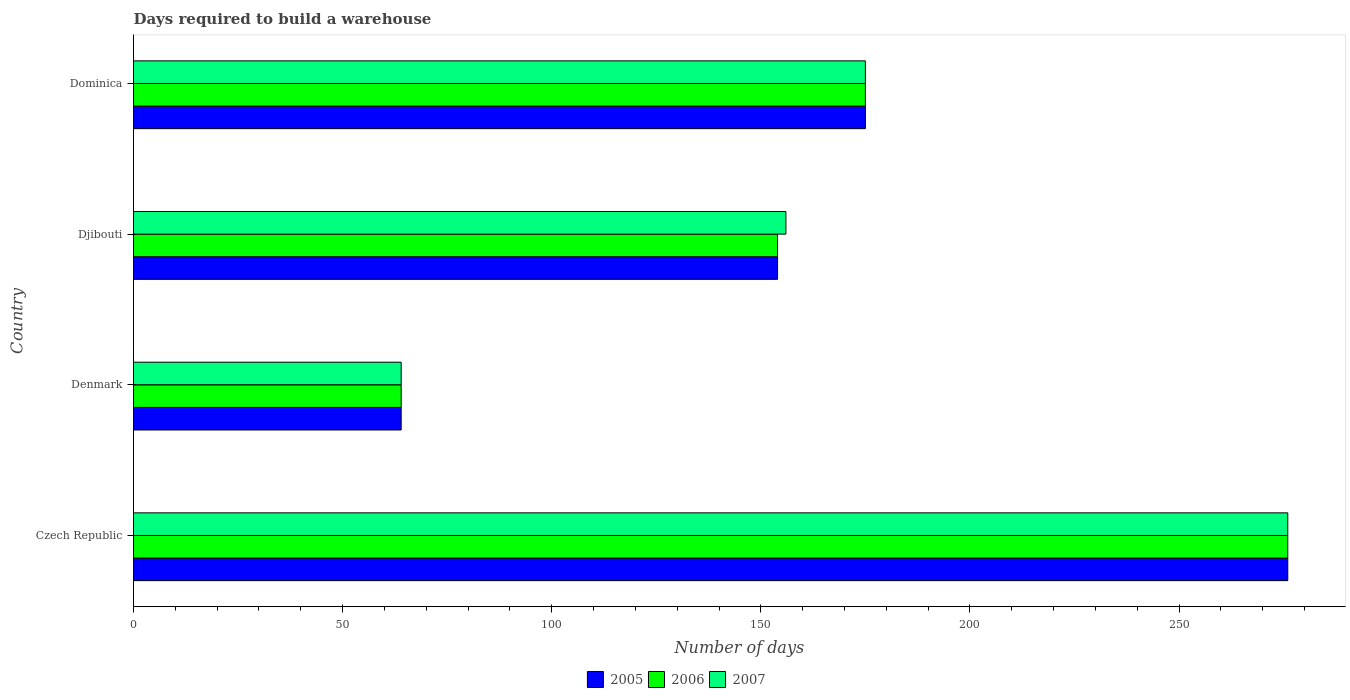How many bars are there on the 3rd tick from the bottom?
Offer a very short reply. 3. In how many cases, is the number of bars for a given country not equal to the number of legend labels?
Give a very brief answer. 0. What is the days required to build a warehouse in in 2005 in Denmark?
Your response must be concise. 64. Across all countries, what is the maximum days required to build a warehouse in in 2007?
Make the answer very short. 276. Across all countries, what is the minimum days required to build a warehouse in in 2005?
Give a very brief answer. 64. In which country was the days required to build a warehouse in in 2007 maximum?
Make the answer very short. Czech Republic. In which country was the days required to build a warehouse in in 2006 minimum?
Your answer should be compact. Denmark. What is the total days required to build a warehouse in in 2007 in the graph?
Make the answer very short. 671. What is the difference between the days required to build a warehouse in in 2006 in Denmark and that in Dominica?
Offer a very short reply. -111. What is the difference between the days required to build a warehouse in in 2006 in Denmark and the days required to build a warehouse in in 2007 in Dominica?
Ensure brevity in your answer.  -111. What is the average days required to build a warehouse in in 2007 per country?
Ensure brevity in your answer.  167.75. What is the ratio of the days required to build a warehouse in in 2005 in Denmark to that in Djibouti?
Offer a very short reply. 0.42. What is the difference between the highest and the second highest days required to build a warehouse in in 2006?
Provide a succinct answer. 101. What is the difference between the highest and the lowest days required to build a warehouse in in 2007?
Offer a very short reply. 212. What does the 1st bar from the top in Czech Republic represents?
Give a very brief answer. 2007. Is it the case that in every country, the sum of the days required to build a warehouse in in 2007 and days required to build a warehouse in in 2006 is greater than the days required to build a warehouse in in 2005?
Your answer should be very brief. Yes. How many bars are there?
Keep it short and to the point. 12. How many countries are there in the graph?
Provide a short and direct response. 4. Are the values on the major ticks of X-axis written in scientific E-notation?
Offer a terse response. No. Does the graph contain any zero values?
Offer a very short reply. No. How are the legend labels stacked?
Your response must be concise. Horizontal. What is the title of the graph?
Provide a short and direct response. Days required to build a warehouse. Does "1965" appear as one of the legend labels in the graph?
Offer a terse response. No. What is the label or title of the X-axis?
Give a very brief answer. Number of days. What is the label or title of the Y-axis?
Your answer should be compact. Country. What is the Number of days of 2005 in Czech Republic?
Ensure brevity in your answer.  276. What is the Number of days of 2006 in Czech Republic?
Ensure brevity in your answer.  276. What is the Number of days in 2007 in Czech Republic?
Offer a terse response. 276. What is the Number of days in 2005 in Djibouti?
Your answer should be very brief. 154. What is the Number of days in 2006 in Djibouti?
Offer a very short reply. 154. What is the Number of days in 2007 in Djibouti?
Provide a succinct answer. 156. What is the Number of days of 2005 in Dominica?
Offer a terse response. 175. What is the Number of days of 2006 in Dominica?
Your answer should be compact. 175. What is the Number of days in 2007 in Dominica?
Your response must be concise. 175. Across all countries, what is the maximum Number of days of 2005?
Provide a short and direct response. 276. Across all countries, what is the maximum Number of days of 2006?
Offer a very short reply. 276. Across all countries, what is the maximum Number of days in 2007?
Offer a terse response. 276. Across all countries, what is the minimum Number of days of 2005?
Your answer should be compact. 64. Across all countries, what is the minimum Number of days of 2006?
Offer a very short reply. 64. Across all countries, what is the minimum Number of days of 2007?
Offer a very short reply. 64. What is the total Number of days of 2005 in the graph?
Provide a succinct answer. 669. What is the total Number of days in 2006 in the graph?
Make the answer very short. 669. What is the total Number of days in 2007 in the graph?
Keep it short and to the point. 671. What is the difference between the Number of days in 2005 in Czech Republic and that in Denmark?
Your answer should be very brief. 212. What is the difference between the Number of days of 2006 in Czech Republic and that in Denmark?
Provide a short and direct response. 212. What is the difference between the Number of days in 2007 in Czech Republic and that in Denmark?
Keep it short and to the point. 212. What is the difference between the Number of days of 2005 in Czech Republic and that in Djibouti?
Your response must be concise. 122. What is the difference between the Number of days of 2006 in Czech Republic and that in Djibouti?
Keep it short and to the point. 122. What is the difference between the Number of days of 2007 in Czech Republic and that in Djibouti?
Ensure brevity in your answer.  120. What is the difference between the Number of days of 2005 in Czech Republic and that in Dominica?
Keep it short and to the point. 101. What is the difference between the Number of days in 2006 in Czech Republic and that in Dominica?
Give a very brief answer. 101. What is the difference between the Number of days of 2007 in Czech Republic and that in Dominica?
Your answer should be very brief. 101. What is the difference between the Number of days in 2005 in Denmark and that in Djibouti?
Make the answer very short. -90. What is the difference between the Number of days of 2006 in Denmark and that in Djibouti?
Provide a succinct answer. -90. What is the difference between the Number of days of 2007 in Denmark and that in Djibouti?
Your response must be concise. -92. What is the difference between the Number of days of 2005 in Denmark and that in Dominica?
Ensure brevity in your answer.  -111. What is the difference between the Number of days of 2006 in Denmark and that in Dominica?
Give a very brief answer. -111. What is the difference between the Number of days of 2007 in Denmark and that in Dominica?
Keep it short and to the point. -111. What is the difference between the Number of days in 2005 in Djibouti and that in Dominica?
Make the answer very short. -21. What is the difference between the Number of days of 2005 in Czech Republic and the Number of days of 2006 in Denmark?
Provide a short and direct response. 212. What is the difference between the Number of days in 2005 in Czech Republic and the Number of days in 2007 in Denmark?
Ensure brevity in your answer.  212. What is the difference between the Number of days in 2006 in Czech Republic and the Number of days in 2007 in Denmark?
Your answer should be very brief. 212. What is the difference between the Number of days of 2005 in Czech Republic and the Number of days of 2006 in Djibouti?
Your answer should be very brief. 122. What is the difference between the Number of days in 2005 in Czech Republic and the Number of days in 2007 in Djibouti?
Keep it short and to the point. 120. What is the difference between the Number of days of 2006 in Czech Republic and the Number of days of 2007 in Djibouti?
Ensure brevity in your answer.  120. What is the difference between the Number of days in 2005 in Czech Republic and the Number of days in 2006 in Dominica?
Make the answer very short. 101. What is the difference between the Number of days in 2005 in Czech Republic and the Number of days in 2007 in Dominica?
Make the answer very short. 101. What is the difference between the Number of days in 2006 in Czech Republic and the Number of days in 2007 in Dominica?
Provide a succinct answer. 101. What is the difference between the Number of days of 2005 in Denmark and the Number of days of 2006 in Djibouti?
Your answer should be compact. -90. What is the difference between the Number of days in 2005 in Denmark and the Number of days in 2007 in Djibouti?
Your answer should be compact. -92. What is the difference between the Number of days of 2006 in Denmark and the Number of days of 2007 in Djibouti?
Make the answer very short. -92. What is the difference between the Number of days of 2005 in Denmark and the Number of days of 2006 in Dominica?
Your response must be concise. -111. What is the difference between the Number of days of 2005 in Denmark and the Number of days of 2007 in Dominica?
Make the answer very short. -111. What is the difference between the Number of days of 2006 in Denmark and the Number of days of 2007 in Dominica?
Provide a succinct answer. -111. What is the difference between the Number of days in 2005 in Djibouti and the Number of days in 2006 in Dominica?
Provide a succinct answer. -21. What is the difference between the Number of days in 2006 in Djibouti and the Number of days in 2007 in Dominica?
Give a very brief answer. -21. What is the average Number of days of 2005 per country?
Provide a succinct answer. 167.25. What is the average Number of days of 2006 per country?
Offer a very short reply. 167.25. What is the average Number of days in 2007 per country?
Keep it short and to the point. 167.75. What is the difference between the Number of days of 2005 and Number of days of 2006 in Czech Republic?
Ensure brevity in your answer.  0. What is the difference between the Number of days in 2005 and Number of days in 2007 in Czech Republic?
Give a very brief answer. 0. What is the difference between the Number of days of 2006 and Number of days of 2007 in Czech Republic?
Offer a terse response. 0. What is the difference between the Number of days in 2005 and Number of days in 2006 in Denmark?
Your answer should be compact. 0. What is the difference between the Number of days in 2005 and Number of days in 2006 in Djibouti?
Your answer should be very brief. 0. What is the difference between the Number of days in 2005 and Number of days in 2007 in Djibouti?
Offer a terse response. -2. What is the difference between the Number of days of 2005 and Number of days of 2007 in Dominica?
Provide a succinct answer. 0. What is the ratio of the Number of days in 2005 in Czech Republic to that in Denmark?
Your response must be concise. 4.31. What is the ratio of the Number of days of 2006 in Czech Republic to that in Denmark?
Make the answer very short. 4.31. What is the ratio of the Number of days of 2007 in Czech Republic to that in Denmark?
Your response must be concise. 4.31. What is the ratio of the Number of days of 2005 in Czech Republic to that in Djibouti?
Give a very brief answer. 1.79. What is the ratio of the Number of days in 2006 in Czech Republic to that in Djibouti?
Provide a short and direct response. 1.79. What is the ratio of the Number of days in 2007 in Czech Republic to that in Djibouti?
Your answer should be very brief. 1.77. What is the ratio of the Number of days of 2005 in Czech Republic to that in Dominica?
Keep it short and to the point. 1.58. What is the ratio of the Number of days in 2006 in Czech Republic to that in Dominica?
Your response must be concise. 1.58. What is the ratio of the Number of days in 2007 in Czech Republic to that in Dominica?
Ensure brevity in your answer.  1.58. What is the ratio of the Number of days of 2005 in Denmark to that in Djibouti?
Give a very brief answer. 0.42. What is the ratio of the Number of days in 2006 in Denmark to that in Djibouti?
Offer a very short reply. 0.42. What is the ratio of the Number of days in 2007 in Denmark to that in Djibouti?
Give a very brief answer. 0.41. What is the ratio of the Number of days of 2005 in Denmark to that in Dominica?
Offer a terse response. 0.37. What is the ratio of the Number of days in 2006 in Denmark to that in Dominica?
Offer a terse response. 0.37. What is the ratio of the Number of days of 2007 in Denmark to that in Dominica?
Your answer should be compact. 0.37. What is the ratio of the Number of days in 2007 in Djibouti to that in Dominica?
Offer a very short reply. 0.89. What is the difference between the highest and the second highest Number of days in 2005?
Offer a very short reply. 101. What is the difference between the highest and the second highest Number of days of 2006?
Offer a very short reply. 101. What is the difference between the highest and the second highest Number of days of 2007?
Make the answer very short. 101. What is the difference between the highest and the lowest Number of days in 2005?
Keep it short and to the point. 212. What is the difference between the highest and the lowest Number of days in 2006?
Ensure brevity in your answer.  212. What is the difference between the highest and the lowest Number of days in 2007?
Offer a very short reply. 212. 